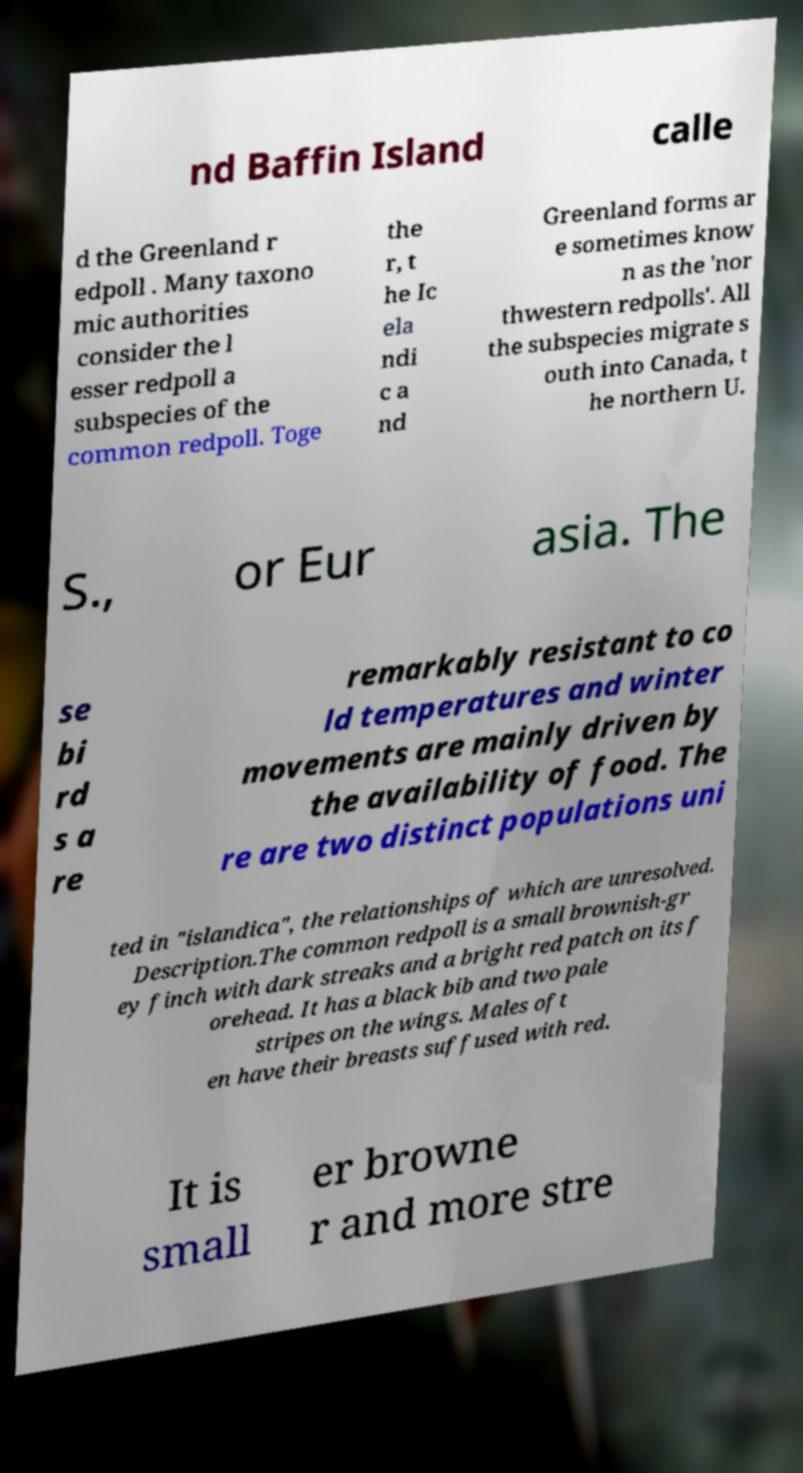Could you assist in decoding the text presented in this image and type it out clearly? nd Baffin Island calle d the Greenland r edpoll . Many taxono mic authorities consider the l esser redpoll a subspecies of the common redpoll. Toge the r, t he Ic ela ndi c a nd Greenland forms ar e sometimes know n as the 'nor thwestern redpolls'. All the subspecies migrate s outh into Canada, t he northern U. S., or Eur asia. The se bi rd s a re remarkably resistant to co ld temperatures and winter movements are mainly driven by the availability of food. The re are two distinct populations uni ted in "islandica", the relationships of which are unresolved. Description.The common redpoll is a small brownish-gr ey finch with dark streaks and a bright red patch on its f orehead. It has a black bib and two pale stripes on the wings. Males oft en have their breasts suffused with red. It is small er browne r and more stre 